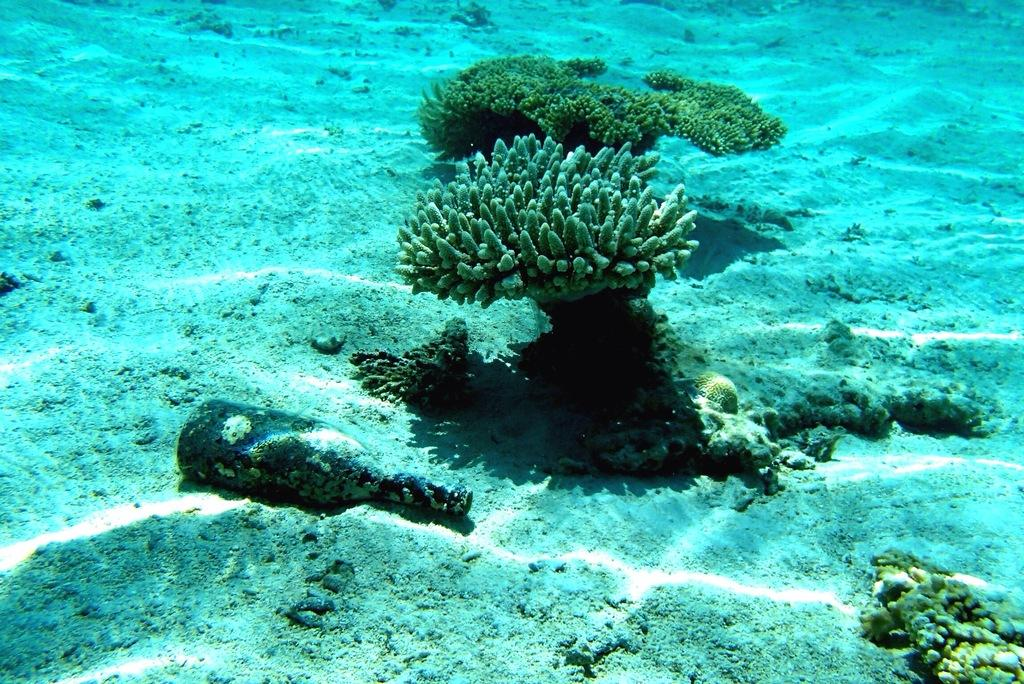What is the primary element visible in the image? There is water in the image. What else can be seen in the image besides water? There are plants and a bottle visible in the image. How does the respect for the plants in the image manifest itself? There is no indication of respect or any emotional connection in the image; it simply shows plants, water, and a bottle. 